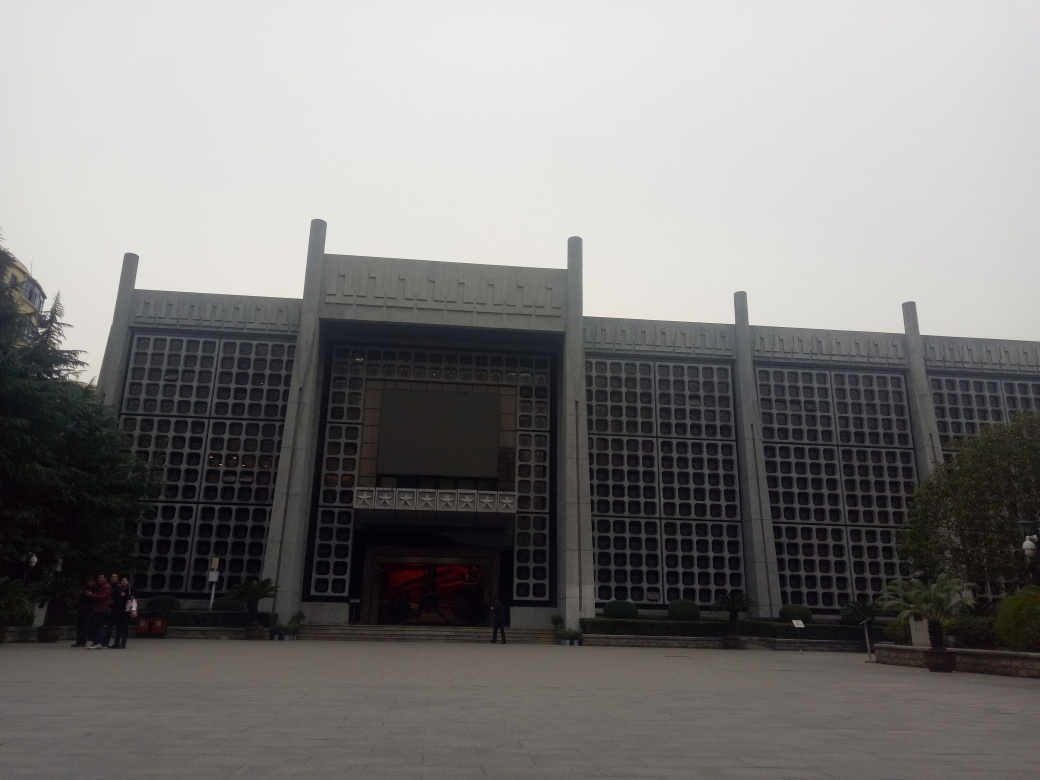What do you think is the function of this building? The building's imposing facade and central entrance, flanked by pilasters, suggest that it could serve a significant public or cultural function. It might be a government building, a museum, a library, or a cultural center, designed to convey a sense of order and importance. What can you say about the use of color in this building's design? The building's color palette is quite restrained, featuring primarily the natural grey tones of concrete or stone. This choice emphasizes the material's authenticity and complements the architectural style's focus on raw textures rather than ornate color schemes. 